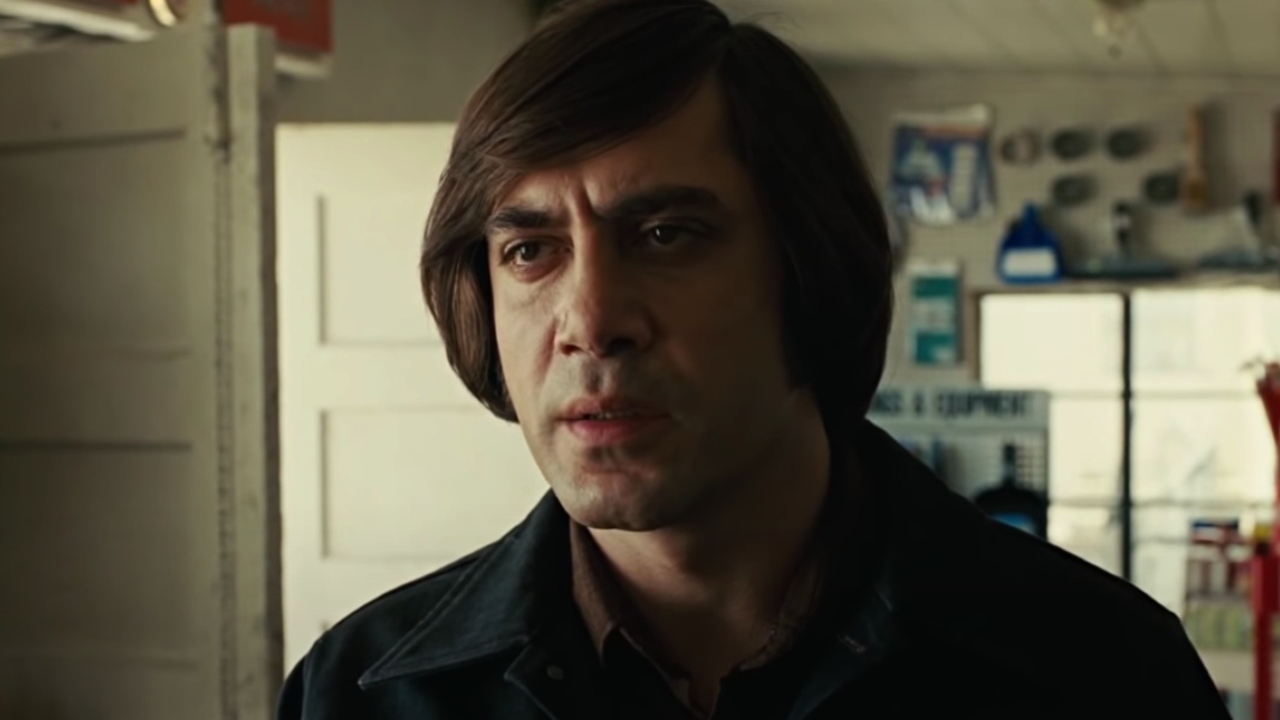Analyze the image in a comprehensive and detailed manner. In this image, we see a man with shoulder-length dark hair, portrayed with a serious and contemplative expression. He is dressed in a black jacket, standing prominently in the foreground. The background suggests a workshop or garage setting, with various tools and equipment visible. This setting might indicate the man is deeply engrossed in his thoughts, perhaps about a challenging task or a significant decision he must make. The overall somber tone of the image, combined with the man's intense expression, creates a narrative of introspection and focus. 